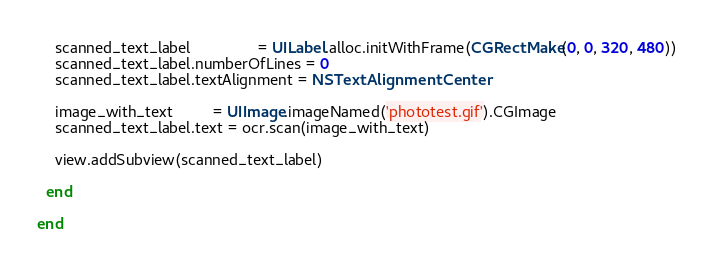<code> <loc_0><loc_0><loc_500><loc_500><_Ruby_>    scanned_text_label               = UILabel.alloc.initWithFrame(CGRectMake(0, 0, 320, 480))
    scanned_text_label.numberOfLines = 0
    scanned_text_label.textAlignment = NSTextAlignmentCenter

    image_with_text         = UIImage.imageNamed('phototest.gif').CGImage
    scanned_text_label.text = ocr.scan(image_with_text)

    view.addSubview(scanned_text_label)

  end

end
</code> 